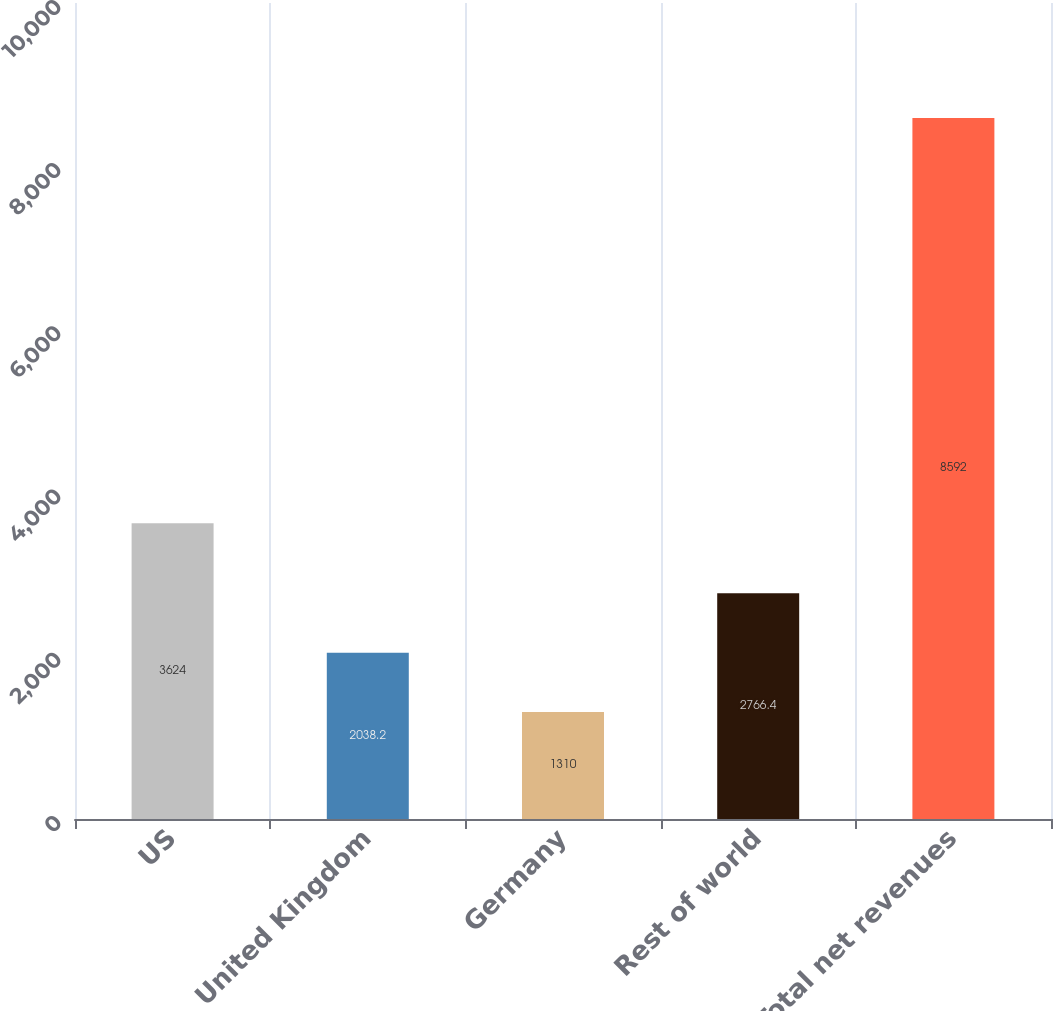Convert chart. <chart><loc_0><loc_0><loc_500><loc_500><bar_chart><fcel>US<fcel>United Kingdom<fcel>Germany<fcel>Rest of world<fcel>Total net revenues<nl><fcel>3624<fcel>2038.2<fcel>1310<fcel>2766.4<fcel>8592<nl></chart> 